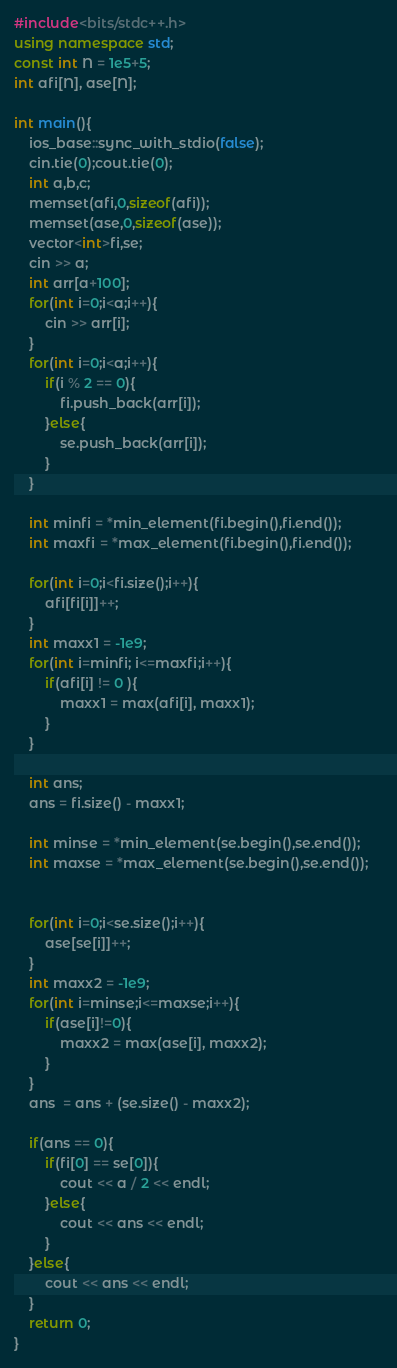<code> <loc_0><loc_0><loc_500><loc_500><_C++_>#include<bits/stdc++.h>
using namespace std;
const int N = 1e5+5;
int afi[N], ase[N];

int main(){
	ios_base::sync_with_stdio(false);
	cin.tie(0);cout.tie(0);
	int a,b,c;
	memset(afi,0,sizeof(afi));
	memset(ase,0,sizeof(ase));
	vector<int>fi,se;
	cin >> a;
	int arr[a+100];
	for(int i=0;i<a;i++){
		cin >> arr[i];
	}
	for(int i=0;i<a;i++){
		if(i % 2 == 0){
			fi.push_back(arr[i]);
		}else{
			se.push_back(arr[i]);
		}
	}
	
	int minfi = *min_element(fi.begin(),fi.end());
	int maxfi = *max_element(fi.begin(),fi.end());
	
	for(int i=0;i<fi.size();i++){
		afi[fi[i]]++;
	}
	int maxx1 = -1e9;
	for(int i=minfi; i<=maxfi;i++){
		if(afi[i] != 0 ){
			maxx1 = max(afi[i], maxx1);
		}
	}
	
	int ans;
	ans = fi.size() - maxx1;
	
	int minse = *min_element(se.begin(),se.end());	
	int maxse = *max_element(se.begin(),se.end());	
	

	for(int i=0;i<se.size();i++){
		ase[se[i]]++;
	}
	int maxx2 = -1e9;
	for(int i=minse;i<=maxse;i++){
		if(ase[i]!=0){
			maxx2 = max(ase[i], maxx2);
		}	
	}
	ans  = ans + (se.size() - maxx2);
	
	if(ans == 0){
		if(fi[0] == se[0]){
			cout << a / 2 << endl;
		}else{
			cout << ans << endl;
		}
	}else{
		cout << ans << endl;
	}
	return 0;
}
</code> 